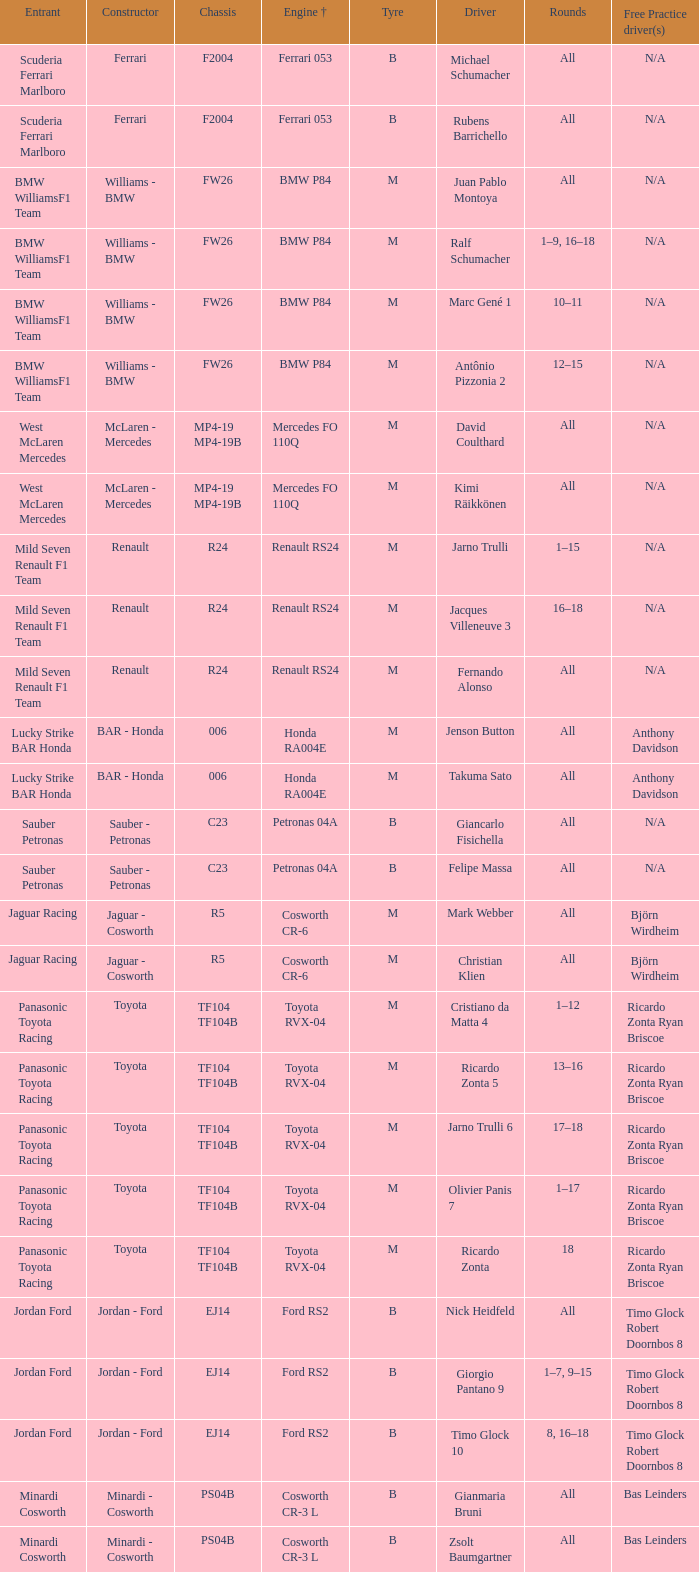What kind of free practice is there with a Ford RS2 engine +? Timo Glock Robert Doornbos 8, Timo Glock Robert Doornbos 8, Timo Glock Robert Doornbos 8. 